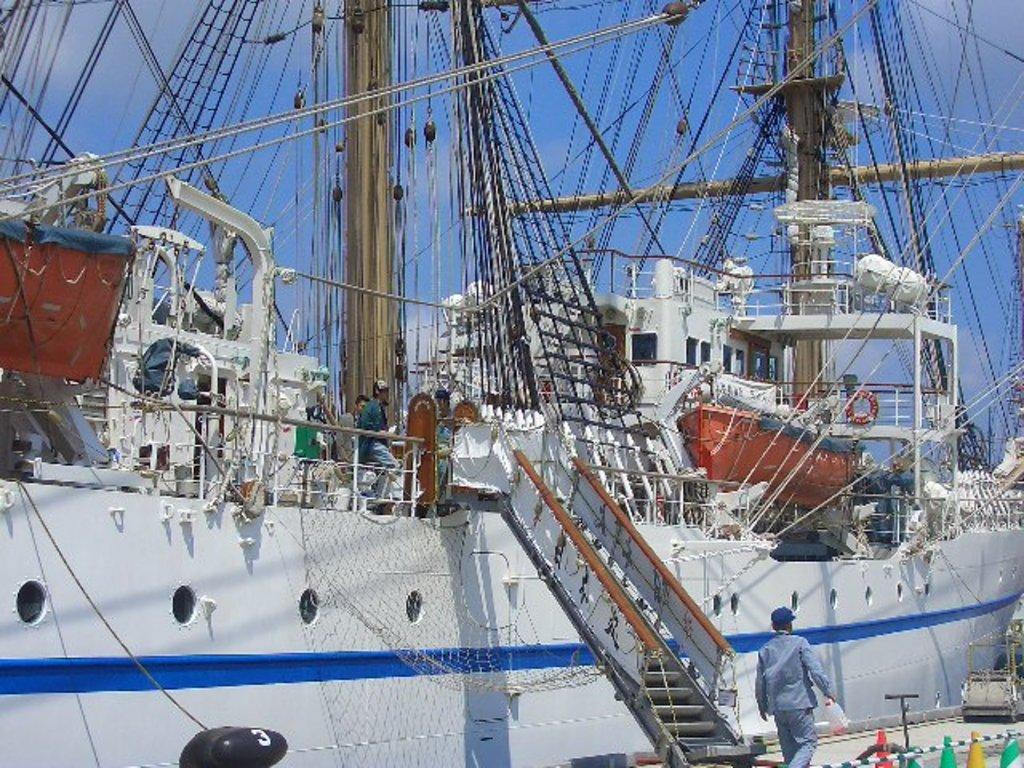What is the main subject of the image? The main subject of the image is a ship. Can you describe the people in the image? There are people in the image, but their specific actions or roles are not mentioned. What can be seen in the background of the image? The sky is visible in the background of the image. What safety equipment is present at the bottom of the image? Traffic cones are present at the bottom of the image. What equipment is visible in the image related to fishing or boating? There is a net and a rope in the image. What other unspecified objects are present at the bottom of the image? There are some unspecified objects at the bottom of the image. What type of brass design can be seen on the ship's railing in the image? There is no mention of brass or any specific design on the ship's railing in the image. How many babies are visible in the image? There is no mention of babies in the image. 